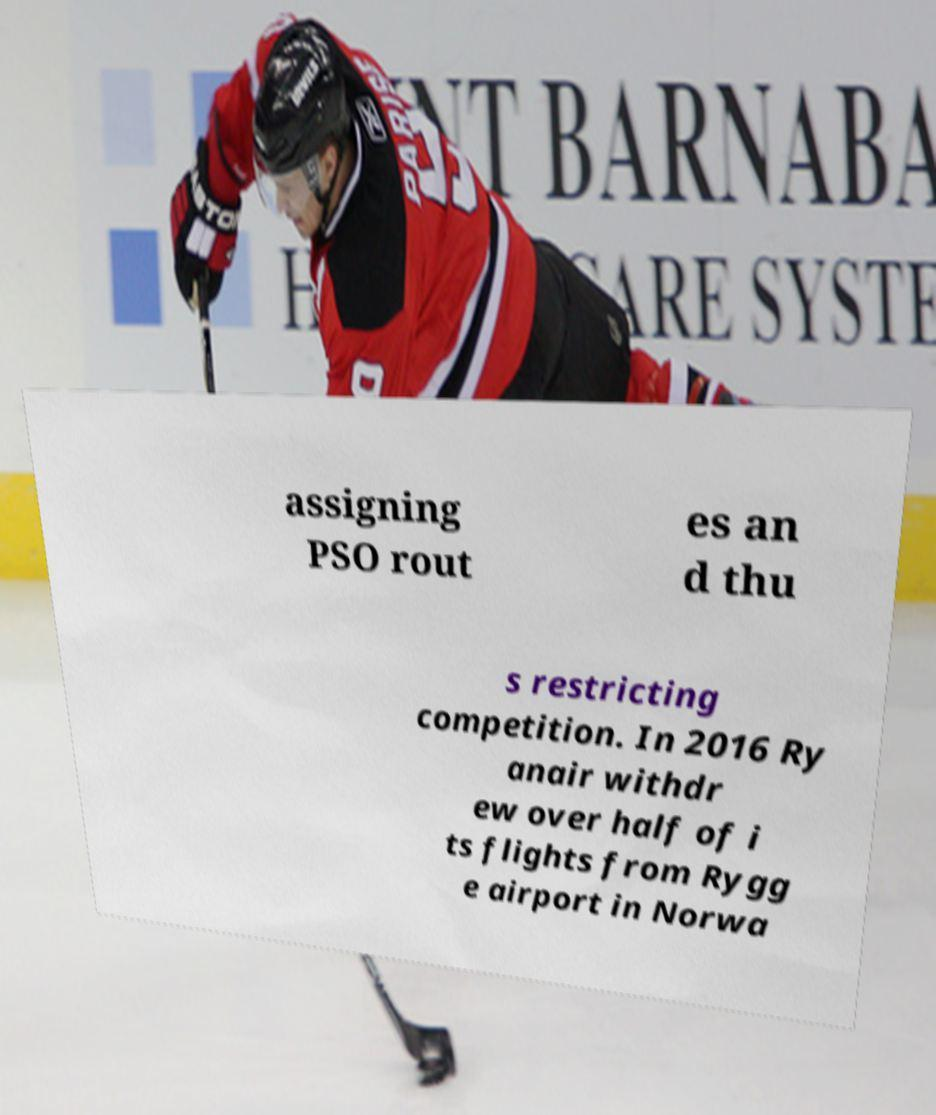Could you extract and type out the text from this image? assigning PSO rout es an d thu s restricting competition. In 2016 Ry anair withdr ew over half of i ts flights from Rygg e airport in Norwa 